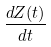Convert formula to latex. <formula><loc_0><loc_0><loc_500><loc_500>\frac { d Z ( t ) } { d t }</formula> 